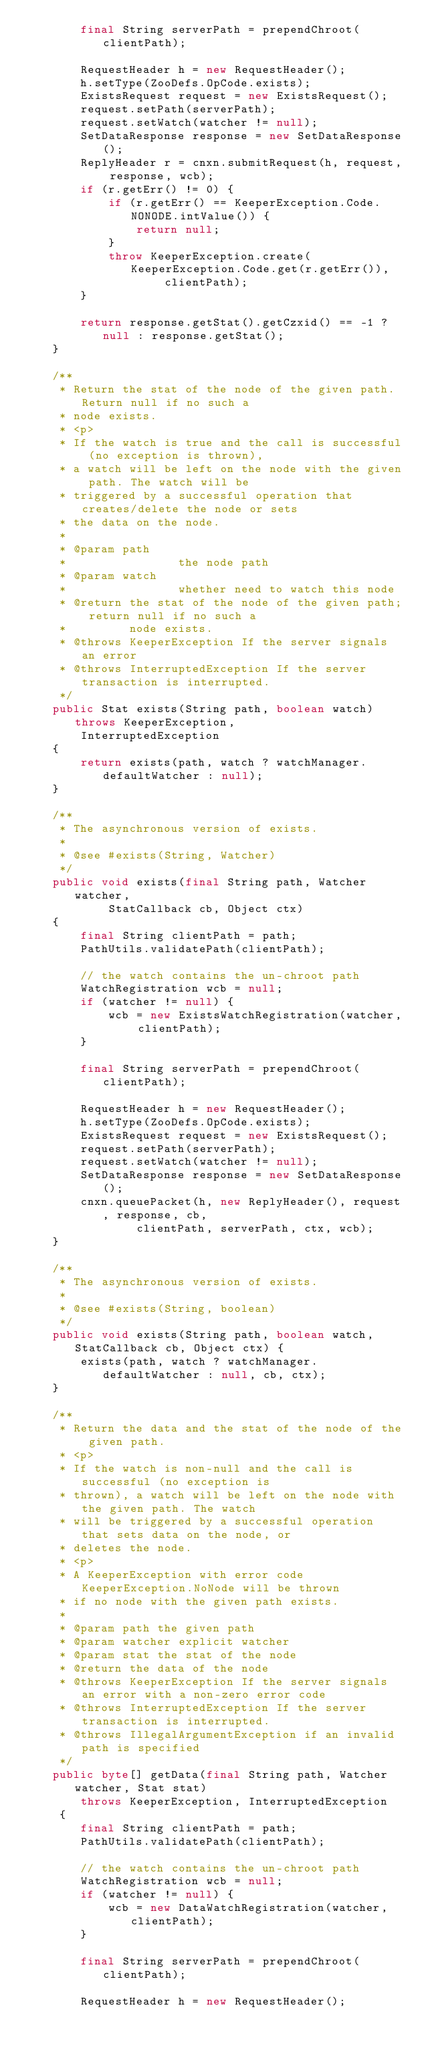<code> <loc_0><loc_0><loc_500><loc_500><_Java_>        final String serverPath = prependChroot(clientPath);

        RequestHeader h = new RequestHeader();
        h.setType(ZooDefs.OpCode.exists);
        ExistsRequest request = new ExistsRequest();
        request.setPath(serverPath);
        request.setWatch(watcher != null);
        SetDataResponse response = new SetDataResponse();
        ReplyHeader r = cnxn.submitRequest(h, request, response, wcb);
        if (r.getErr() != 0) {
            if (r.getErr() == KeeperException.Code.NONODE.intValue()) {
                return null;
            }
            throw KeeperException.create(KeeperException.Code.get(r.getErr()),
                    clientPath);
        }

        return response.getStat().getCzxid() == -1 ? null : response.getStat();
    }

    /**
     * Return the stat of the node of the given path. Return null if no such a
     * node exists.
     * <p>
     * If the watch is true and the call is successful (no exception is thrown),
     * a watch will be left on the node with the given path. The watch will be
     * triggered by a successful operation that creates/delete the node or sets
     * the data on the node.
     *
     * @param path
     *                the node path
     * @param watch
     *                whether need to watch this node
     * @return the stat of the node of the given path; return null if no such a
     *         node exists.
     * @throws KeeperException If the server signals an error
     * @throws InterruptedException If the server transaction is interrupted.
     */
    public Stat exists(String path, boolean watch) throws KeeperException,
        InterruptedException
    {
        return exists(path, watch ? watchManager.defaultWatcher : null);
    }

    /**
     * The asynchronous version of exists.
     *
     * @see #exists(String, Watcher)
     */
    public void exists(final String path, Watcher watcher,
            StatCallback cb, Object ctx)
    {
        final String clientPath = path;
        PathUtils.validatePath(clientPath);

        // the watch contains the un-chroot path
        WatchRegistration wcb = null;
        if (watcher != null) {
            wcb = new ExistsWatchRegistration(watcher, clientPath);
        }

        final String serverPath = prependChroot(clientPath);

        RequestHeader h = new RequestHeader();
        h.setType(ZooDefs.OpCode.exists);
        ExistsRequest request = new ExistsRequest();
        request.setPath(serverPath);
        request.setWatch(watcher != null);
        SetDataResponse response = new SetDataResponse();
        cnxn.queuePacket(h, new ReplyHeader(), request, response, cb,
                clientPath, serverPath, ctx, wcb);
    }

    /**
     * The asynchronous version of exists.
     *
     * @see #exists(String, boolean)
     */
    public void exists(String path, boolean watch, StatCallback cb, Object ctx) {
        exists(path, watch ? watchManager.defaultWatcher : null, cb, ctx);
    }

    /**
     * Return the data and the stat of the node of the given path.
     * <p>
     * If the watch is non-null and the call is successful (no exception is
     * thrown), a watch will be left on the node with the given path. The watch
     * will be triggered by a successful operation that sets data on the node, or
     * deletes the node.
     * <p>
     * A KeeperException with error code KeeperException.NoNode will be thrown
     * if no node with the given path exists.
     *
     * @param path the given path
     * @param watcher explicit watcher
     * @param stat the stat of the node
     * @return the data of the node
     * @throws KeeperException If the server signals an error with a non-zero error code
     * @throws InterruptedException If the server transaction is interrupted.
     * @throws IllegalArgumentException if an invalid path is specified
     */
    public byte[] getData(final String path, Watcher watcher, Stat stat)
        throws KeeperException, InterruptedException
     {
        final String clientPath = path;
        PathUtils.validatePath(clientPath);

        // the watch contains the un-chroot path
        WatchRegistration wcb = null;
        if (watcher != null) {
            wcb = new DataWatchRegistration(watcher, clientPath);
        }

        final String serverPath = prependChroot(clientPath);

        RequestHeader h = new RequestHeader();</code> 